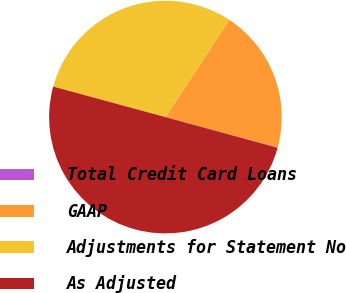Convert chart to OTSL. <chart><loc_0><loc_0><loc_500><loc_500><pie_chart><fcel>Total Credit Card Loans<fcel>GAAP<fcel>Adjustments for Statement No<fcel>As Adjusted<nl><fcel>0.04%<fcel>19.96%<fcel>30.02%<fcel>49.98%<nl></chart> 